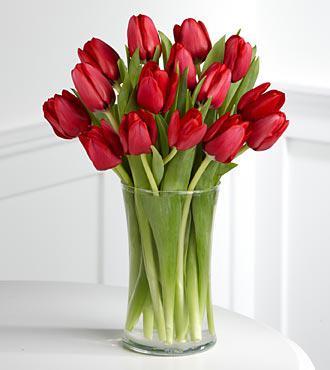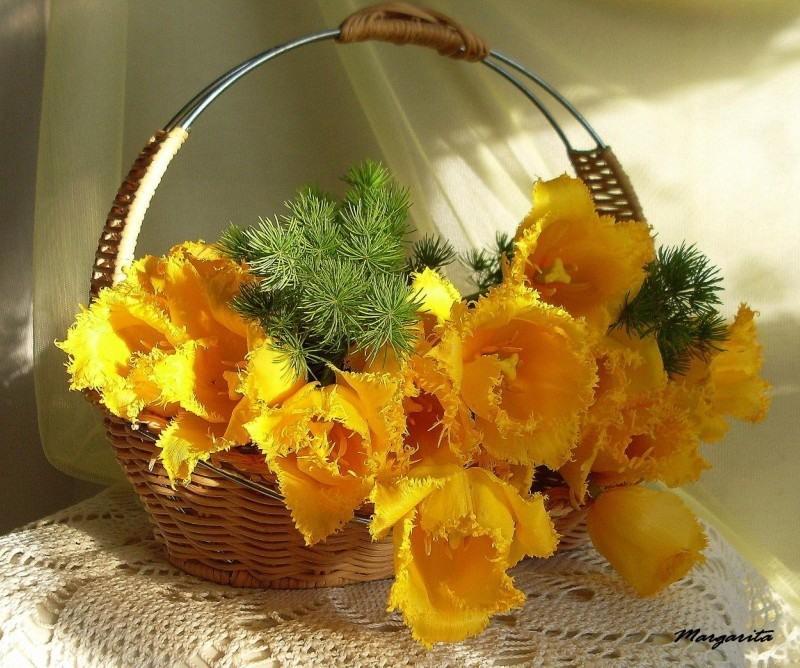The first image is the image on the left, the second image is the image on the right. Examine the images to the left and right. Is the description "There is a clear glass vase with red tulips in one image and a bouquet in a different kind of container in the second image." accurate? Answer yes or no. Yes. The first image is the image on the left, the second image is the image on the right. For the images shown, is this caption "A clear glass vase of yellow and orange tulips is near a sofa in front of a window." true? Answer yes or no. No. 